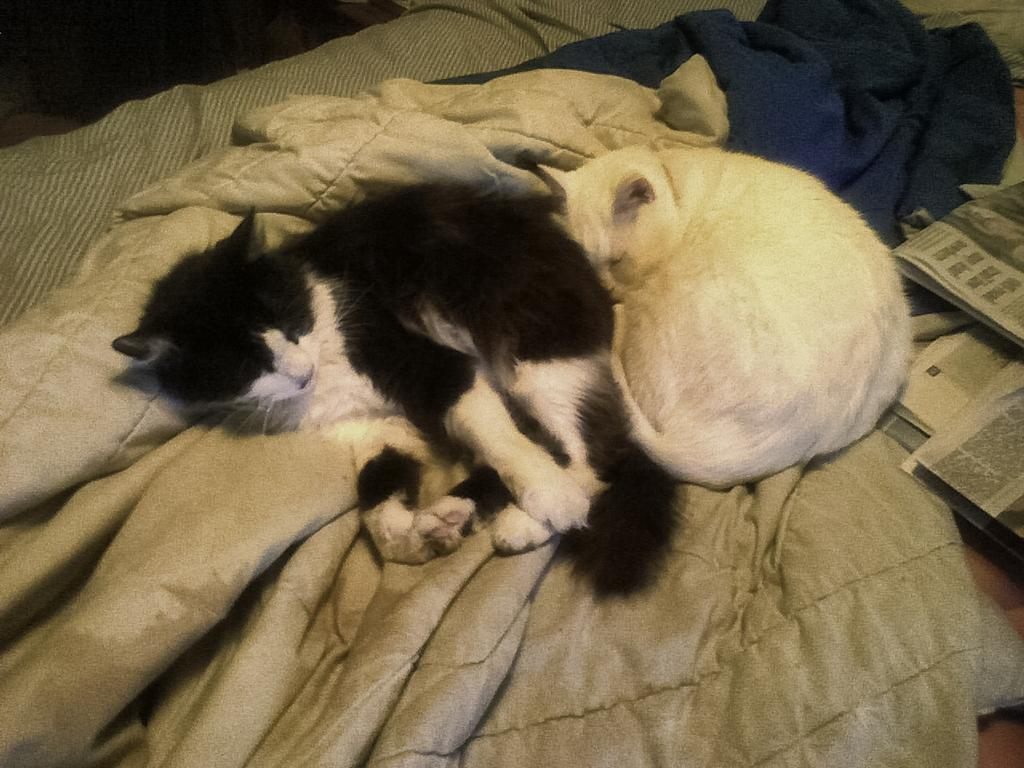What type of animals are present in the image? There are cats in the image. What objects are associated with the cats in the image? There are blankets in the image. Where are the cats and blankets located? They are on a bed in the image. What can be seen on the right side of the image? There are newspapers on the right side of the image. What type of polish is being applied to the rail in the image? There is no rail or polish present in the image. Can you describe the faucet in the image? There is no faucet present in the image. 